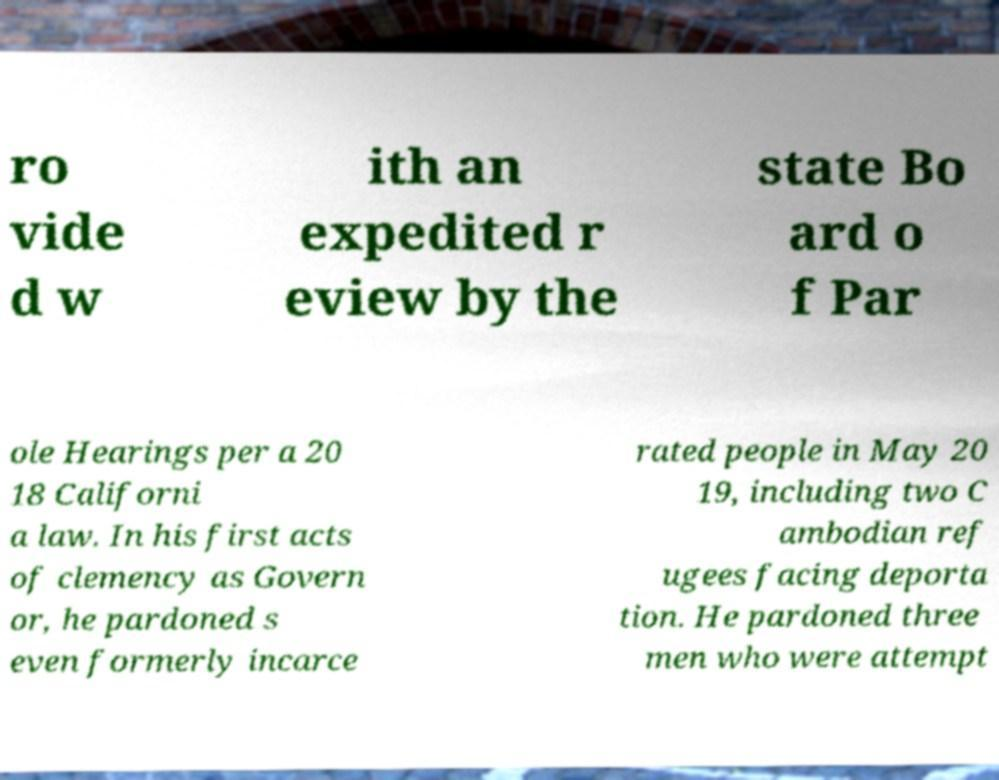Could you assist in decoding the text presented in this image and type it out clearly? ro vide d w ith an expedited r eview by the state Bo ard o f Par ole Hearings per a 20 18 Californi a law. In his first acts of clemency as Govern or, he pardoned s even formerly incarce rated people in May 20 19, including two C ambodian ref ugees facing deporta tion. He pardoned three men who were attempt 